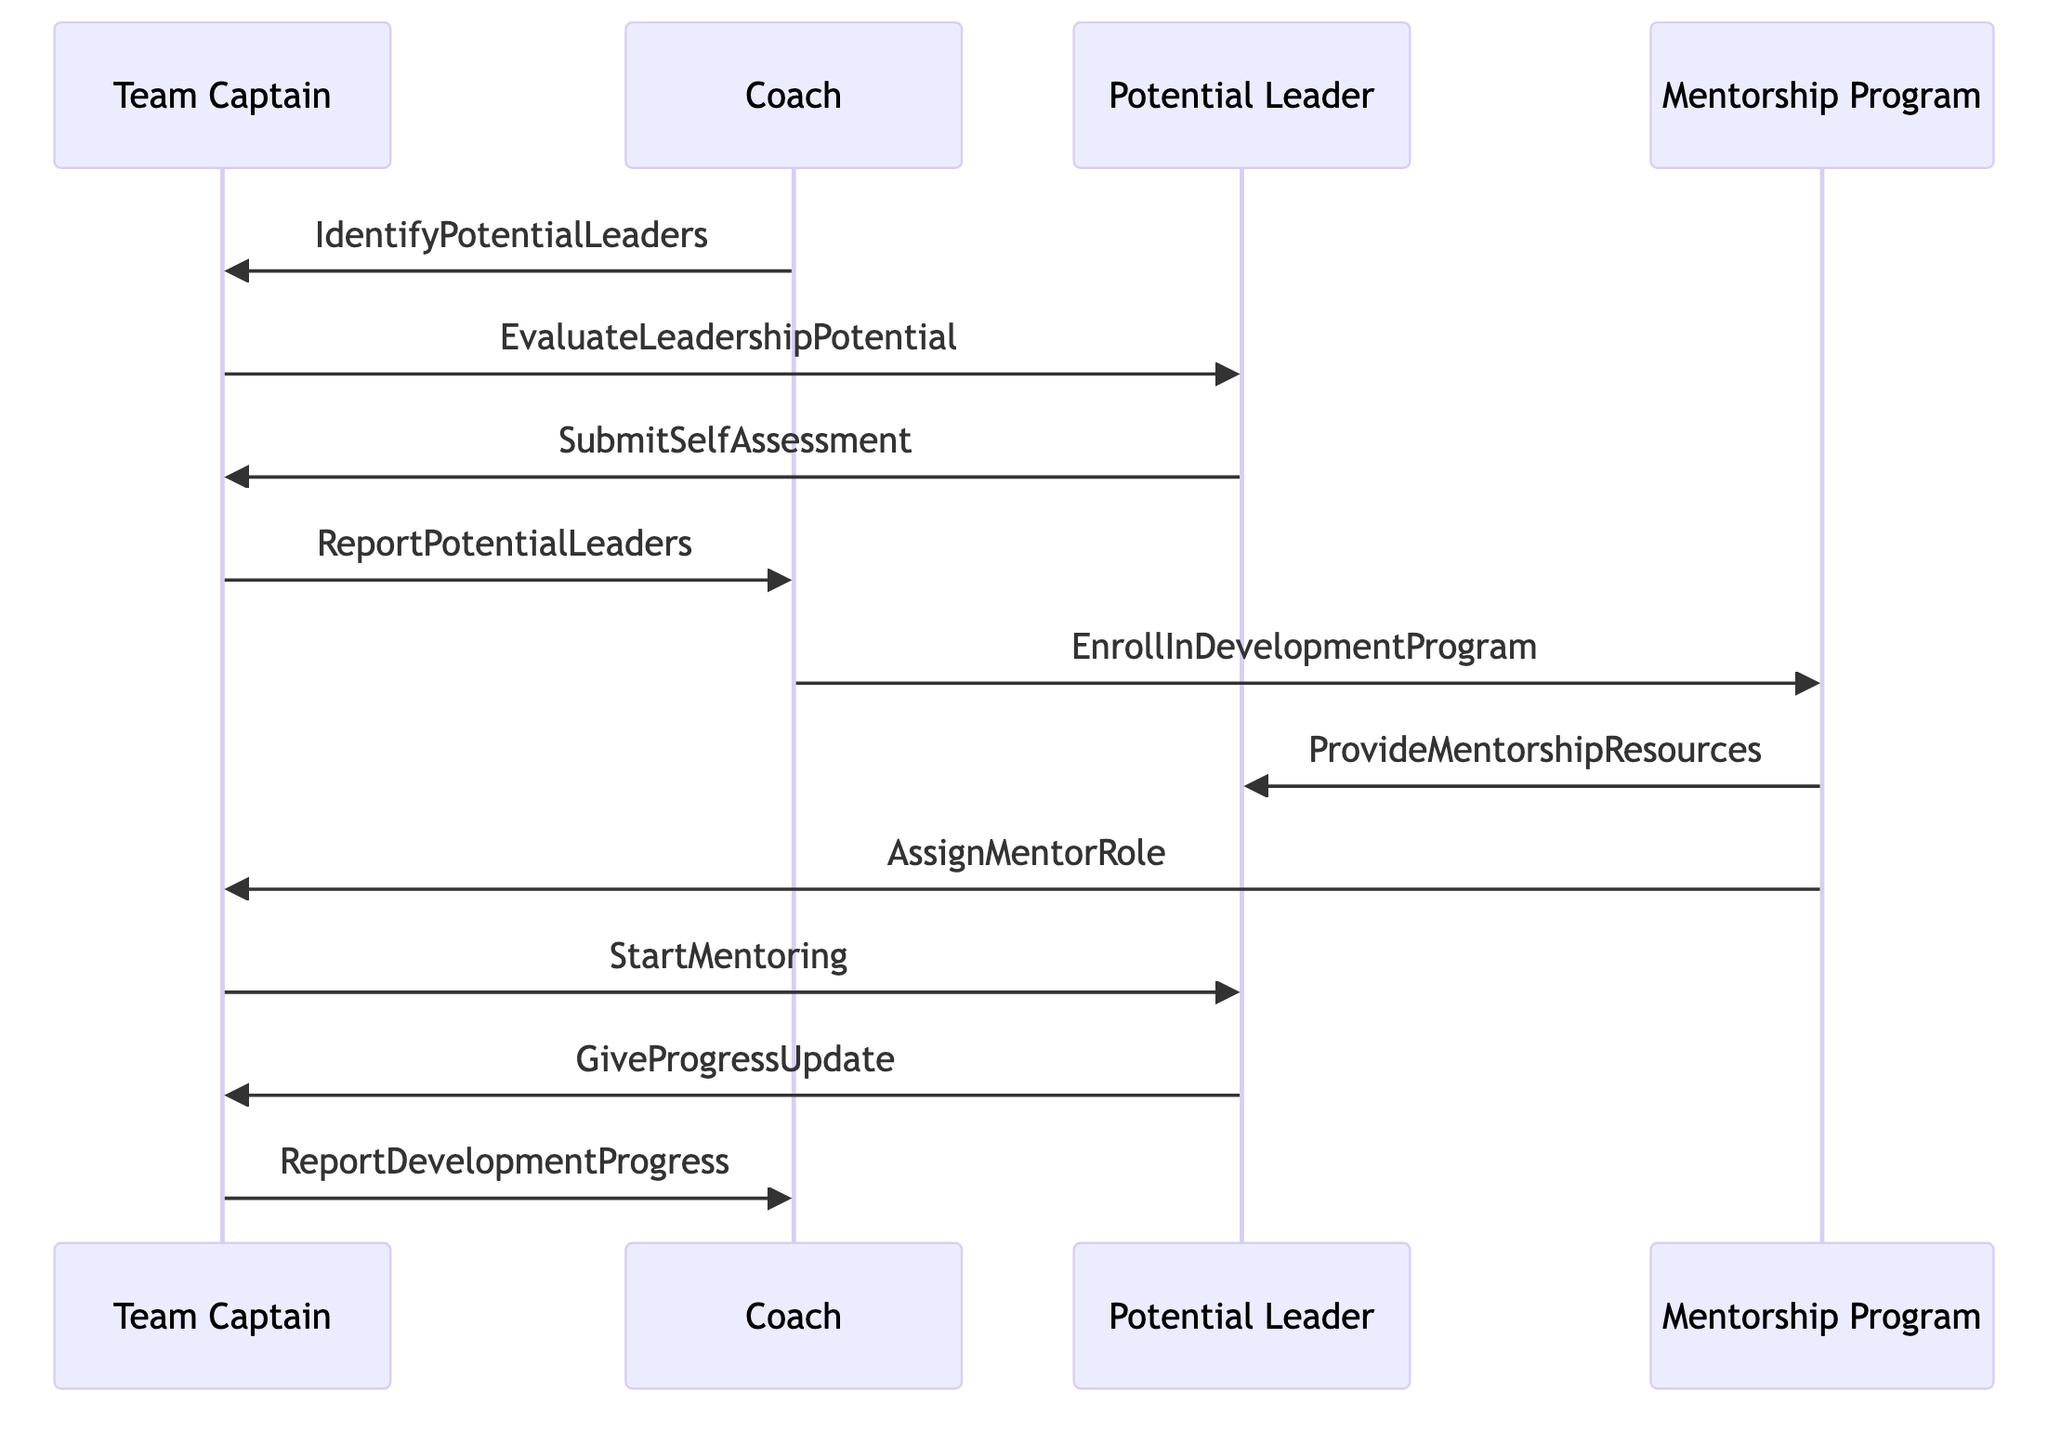What is the role of C in the diagram? "C" represents the Coach, who is the Head Coach responsible for overseeing the leadership development process.
Answer: Head Coach How many participants are involved in the diagram? There are four participants: Team Captain, Coach, Potential Leader, and Mentorship Program. Counting them gives a total of four.
Answer: 4 What message does the Team Captain send to the Coach after evaluating leadership potential? The Team Captain reports the potential leaders to the Coach, indicating the next step in the process after evaluation.
Answer: ReportPotentialLeaders Who provides mentorship resources to the Potential Leader? The Mentorship Program provides the necessary resources to support the growth and development of the Potential Leader.
Answer: ProvideMentorshipResources What is the last step that the Team Captain performs in the sequence? The Team Captain reports the development progress, concluding the sequence of interactions regarding the mentoring process.
Answer: ReportDevelopmentProgress What do the Team Captain and Potential Leader do after the Potential Leader submits a self-assessment? The Team Captain starts mentoring the Potential Leader after receiving their self-assessment, indicating a transition to active engagement in their development.
Answer: StartMentoring What does the Coach do after enrolling the Potential Leader in the development program? The Coach communicates with the Mentorship Program to enroll the Potential Leader, facilitating their participation in the program designed for leadership growth.
Answer: EnrollInDevelopmentProgram What is the role of the Mentorship Program Coordinator in this sequence? The Mentorship Program Coordinator is responsible for coordinating resources and assigning mentorship roles, crucial for the leadership development structure.
Answer: Development Program Coordinator How does the Potential Leader communicate progress to the Team Captain? The Potential Leader gives progress updates to the Team Captain, ensuring ongoing communication and feedback regarding their development.
Answer: GiveProgressUpdate 